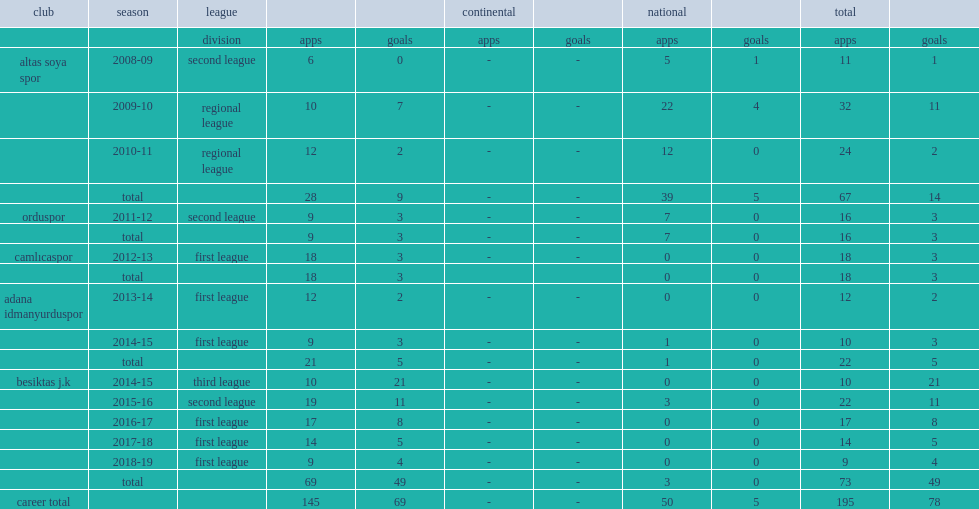In the second half of the 2014-15 season, which league was gizem gonultas transferred to the besiktas j.k. side of? Third league. 